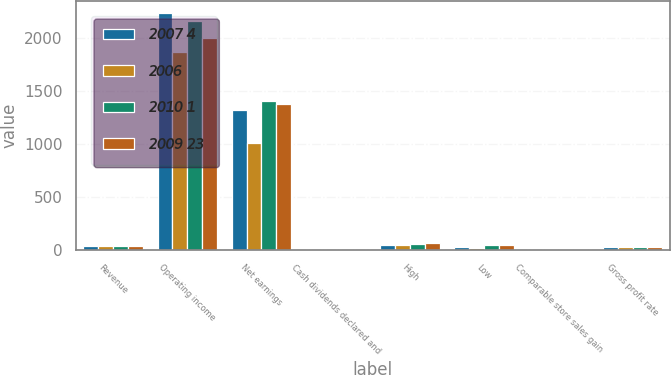Convert chart to OTSL. <chart><loc_0><loc_0><loc_500><loc_500><stacked_bar_chart><ecel><fcel>Revenue<fcel>Operating income<fcel>Net earnings<fcel>Cash dividends declared and<fcel>High<fcel>Low<fcel>Comparable store sales gain<fcel>Gross profit rate<nl><fcel>2007 4<fcel>33.175<fcel>2235<fcel>1317<fcel>0.56<fcel>45.55<fcel>23.97<fcel>0.6<fcel>24.5<nl><fcel>2006<fcel>33.175<fcel>1870<fcel>1003<fcel>0.54<fcel>48.03<fcel>16.42<fcel>1.3<fcel>24.4<nl><fcel>2010 1<fcel>33.175<fcel>2161<fcel>1407<fcel>0.46<fcel>53.9<fcel>41.85<fcel>2.9<fcel>23.9<nl><fcel>2009 23<fcel>33.175<fcel>1999<fcel>1377<fcel>0.36<fcel>59.5<fcel>43.51<fcel>5<fcel>24.4<nl></chart> 